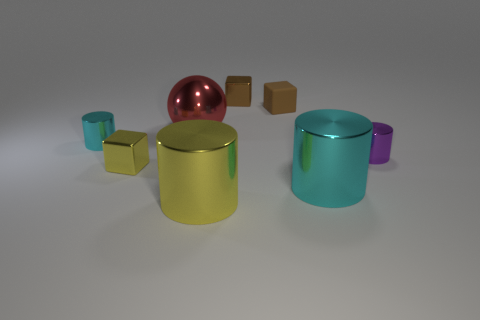There is a shiny object that is both behind the small cyan metallic thing and in front of the rubber block; what is its size? The shiny object in question appears to be a large, spherical object with a reflective surface. Its size relative to the other items in the image suggests it's quite sizable, likely the largest object present. 